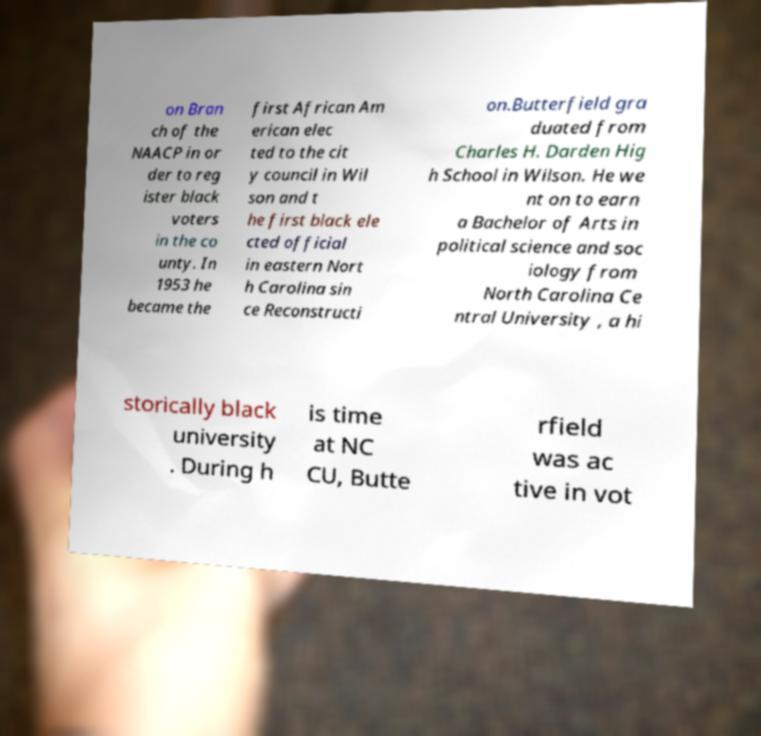Can you accurately transcribe the text from the provided image for me? on Bran ch of the NAACP in or der to reg ister black voters in the co unty. In 1953 he became the first African Am erican elec ted to the cit y council in Wil son and t he first black ele cted official in eastern Nort h Carolina sin ce Reconstructi on.Butterfield gra duated from Charles H. Darden Hig h School in Wilson. He we nt on to earn a Bachelor of Arts in political science and soc iology from North Carolina Ce ntral University , a hi storically black university . During h is time at NC CU, Butte rfield was ac tive in vot 